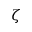<formula> <loc_0><loc_0><loc_500><loc_500>\zeta</formula> 